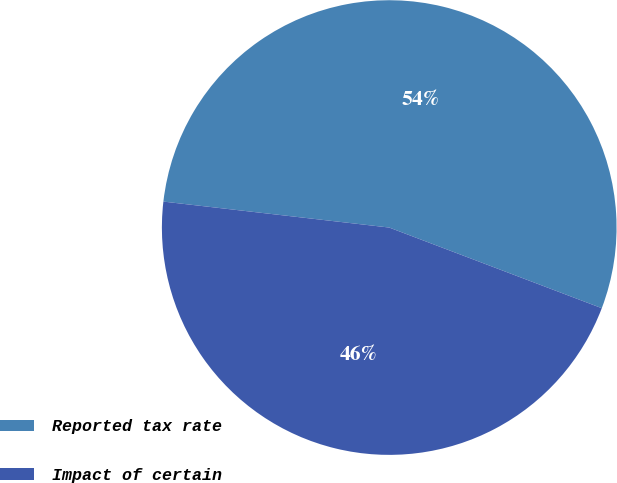<chart> <loc_0><loc_0><loc_500><loc_500><pie_chart><fcel>Reported tax rate<fcel>Impact of certain<nl><fcel>53.95%<fcel>46.05%<nl></chart> 